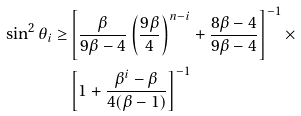<formula> <loc_0><loc_0><loc_500><loc_500>\sin ^ { 2 } \theta _ { i } \geq & \left [ \frac { \beta } { 9 \beta - 4 } \left ( \frac { 9 \beta } { 4 } \right ) ^ { n - i } + \frac { 8 \beta - 4 } { 9 \beta - 4 } \right ] ^ { - 1 } \times \\ & \left [ 1 + \frac { \beta ^ { i } - \beta } { 4 ( \beta - 1 ) } \right ] ^ { - 1 }</formula> 